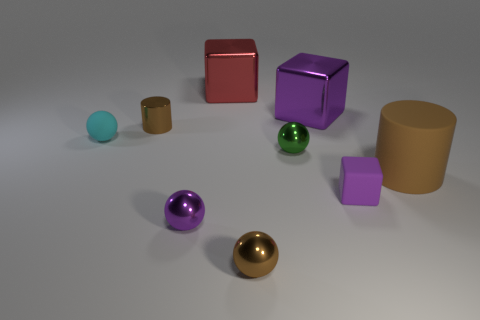Add 1 blue metal things. How many objects exist? 10 Subtract all cubes. How many objects are left? 6 Subtract 2 brown cylinders. How many objects are left? 7 Subtract all tiny yellow cubes. Subtract all red blocks. How many objects are left? 8 Add 8 big metal blocks. How many big metal blocks are left? 10 Add 2 tiny gray cylinders. How many tiny gray cylinders exist? 2 